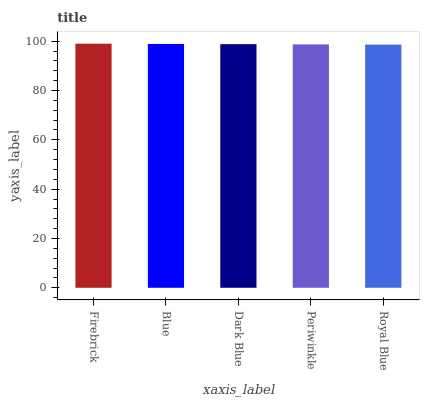Is Royal Blue the minimum?
Answer yes or no. Yes. Is Firebrick the maximum?
Answer yes or no. Yes. Is Blue the minimum?
Answer yes or no. No. Is Blue the maximum?
Answer yes or no. No. Is Firebrick greater than Blue?
Answer yes or no. Yes. Is Blue less than Firebrick?
Answer yes or no. Yes. Is Blue greater than Firebrick?
Answer yes or no. No. Is Firebrick less than Blue?
Answer yes or no. No. Is Dark Blue the high median?
Answer yes or no. Yes. Is Dark Blue the low median?
Answer yes or no. Yes. Is Periwinkle the high median?
Answer yes or no. No. Is Royal Blue the low median?
Answer yes or no. No. 